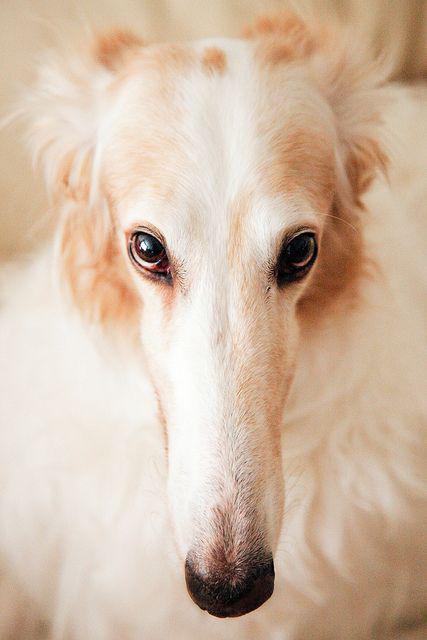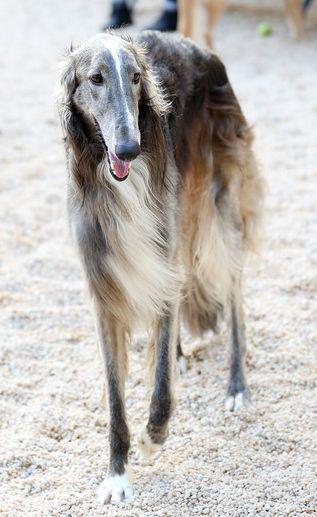The first image is the image on the left, the second image is the image on the right. Considering the images on both sides, is "The dog in the image on the right is lying down." valid? Answer yes or no. No. The first image is the image on the left, the second image is the image on the right. For the images displayed, is the sentence "Each image contains a single hound dog, and one image shows a dog in a reclining position with both front paws extended forward." factually correct? Answer yes or no. No. 